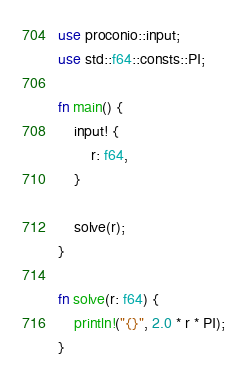<code> <loc_0><loc_0><loc_500><loc_500><_Rust_>use proconio::input;
use std::f64::consts::PI;

fn main() {
    input! {
        r: f64,
    }

    solve(r);
}

fn solve(r: f64) {
    println!("{}", 2.0 * r * PI);
}
</code> 